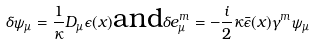Convert formula to latex. <formula><loc_0><loc_0><loc_500><loc_500>\delta \psi _ { \mu } = \frac { 1 } { \kappa } D _ { \mu } \epsilon ( x ) \text {and} \delta e _ { \mu } ^ { m } = - \frac { i } { 2 } \kappa \bar { \epsilon } ( x ) \gamma ^ { m } \psi _ { \mu }</formula> 